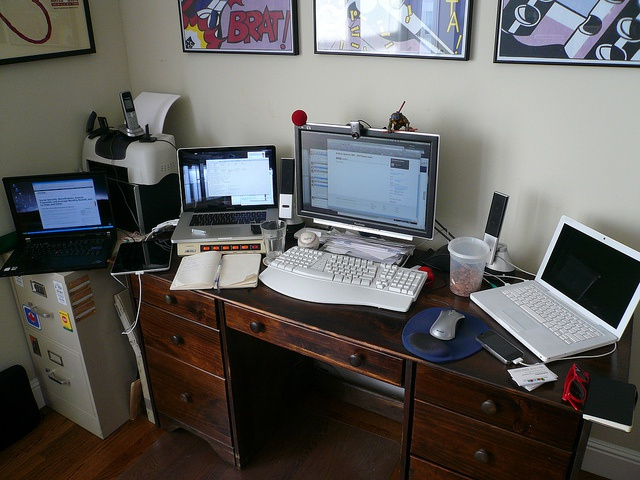Describe the objects in this image and their specific colors. I can see tv in gray, darkgray, and black tones, laptop in gray, black, darkgray, and lightgray tones, laptop in gray and black tones, laptop in gray, black, and lightblue tones, and keyboard in gray, lightgray, and darkgray tones in this image. 